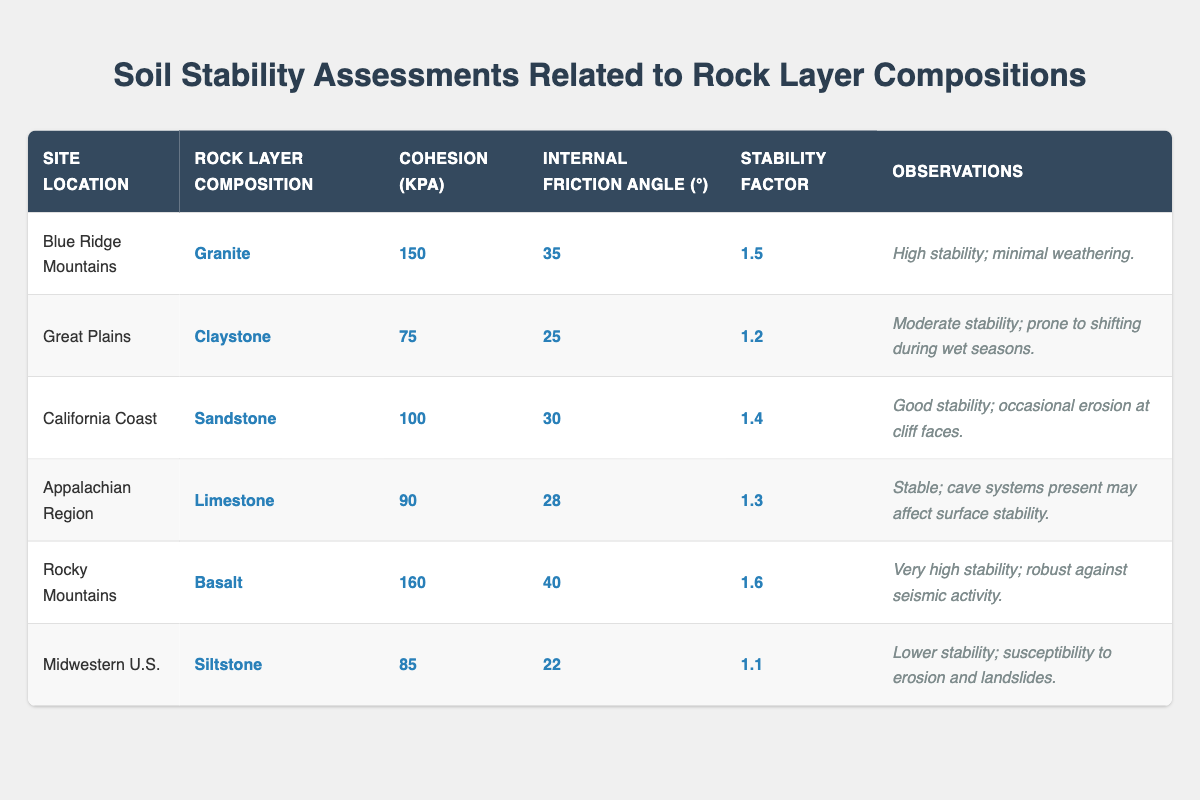What is the rock layer composition at the Rocky Mountains? The table lists the rock layer composition for each site, and for the Rocky Mountains, it states "Basalt."
Answer: Basalt Which site has the highest cohesion value in kPa? By looking at the cohesion values in the table, we see the highest value of 160 kPa is listed for the Rocky Mountains (Basalt).
Answer: Rocky Mountains What is the stability factor for the Great Plains? The table shows the stability factor for the Great Plains is listed as 1.2.
Answer: 1.2 Is the internal friction angle for Siltstone higher than 25 degrees? The internal friction angle for Siltstone is 22 degrees, which is lower than 25 degrees, making the statement false.
Answer: No Which rock layer composition has the highest internal friction angle? By examining the internal friction angles, Basalt from the Rocky Mountains has the highest value of 40 degrees.
Answer: Basalt What is the average cohesion of the rock layers listed in the table? The cohesion values are 150, 75, 100, 90, 160, and 85. Adding them gives 150 + 75 + 100 + 90 + 160 + 85 = 660. There are 6 sites, so the average is 660 / 6 = 110.
Answer: 110 Which site has lower stability: the Midwestern U.S. or the Great Plains? The stability factors show the Midwestern U.S. has a stability factor of 1.1 and Great Plains has 1.2. Since 1.1 is lower than 1.2, the Midwestern U.S. is less stable.
Answer: Midwestern U.S How many sites have a stability factor greater than 1.4? The sites with stability factors greater than 1.4 are Blue Ridge Mountains (1.5), Rocky Mountains (1.6), and California Coast (1.4). This totals three sites.
Answer: 3 What general observation can be made about the sites with high cohesion values? Observing that both the Rocky Mountains (160 kPa) and Blue Ridge Mountains (150 kPa) have high cohesion, both are noted for high stability and minimal weathering, indicating a correlation between high cohesion and stability.
Answer: High stability Do any of the sites have observations mentioning erosion? Yes, both California Coast and Midwestern U.S. contain observations about erosion, indicating susceptibility to such issues.
Answer: Yes What stability factor would you expect for a site with a cohesion of 75 kPa based on its observations? The site with a cohesion of 75 kPa is Great Plains with a stability factor of 1.2, associated with moderate stability and shifting during wet seasons. Thus, expect a similar moderate stability.
Answer: Moderate stability 